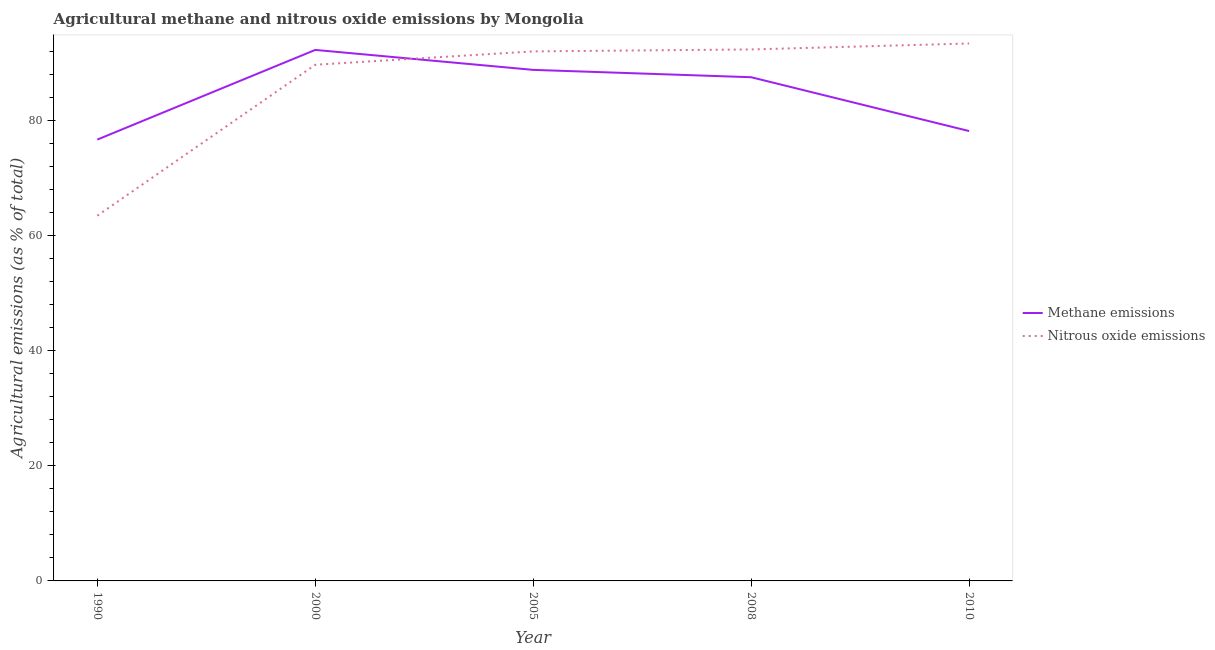How many different coloured lines are there?
Your answer should be very brief. 2. What is the amount of methane emissions in 2010?
Your answer should be very brief. 78.14. Across all years, what is the maximum amount of methane emissions?
Offer a very short reply. 92.24. Across all years, what is the minimum amount of methane emissions?
Your response must be concise. 76.66. In which year was the amount of methane emissions minimum?
Offer a terse response. 1990. What is the total amount of methane emissions in the graph?
Your answer should be compact. 423.3. What is the difference between the amount of nitrous oxide emissions in 2008 and that in 2010?
Provide a succinct answer. -1.03. What is the difference between the amount of nitrous oxide emissions in 2005 and the amount of methane emissions in 1990?
Keep it short and to the point. 15.32. What is the average amount of nitrous oxide emissions per year?
Offer a terse response. 86.15. In the year 2010, what is the difference between the amount of methane emissions and amount of nitrous oxide emissions?
Your response must be concise. -15.21. In how many years, is the amount of nitrous oxide emissions greater than 52 %?
Give a very brief answer. 5. What is the ratio of the amount of methane emissions in 2008 to that in 2010?
Provide a succinct answer. 1.12. Is the amount of methane emissions in 1990 less than that in 2005?
Your answer should be very brief. Yes. What is the difference between the highest and the second highest amount of nitrous oxide emissions?
Provide a short and direct response. 1.03. What is the difference between the highest and the lowest amount of methane emissions?
Offer a terse response. 15.58. In how many years, is the amount of methane emissions greater than the average amount of methane emissions taken over all years?
Your answer should be compact. 3. Is the sum of the amount of methane emissions in 1990 and 2000 greater than the maximum amount of nitrous oxide emissions across all years?
Ensure brevity in your answer.  Yes. Does the amount of nitrous oxide emissions monotonically increase over the years?
Offer a very short reply. Yes. Is the amount of methane emissions strictly greater than the amount of nitrous oxide emissions over the years?
Keep it short and to the point. No. Is the amount of methane emissions strictly less than the amount of nitrous oxide emissions over the years?
Your response must be concise. No. How many years are there in the graph?
Provide a succinct answer. 5. What is the difference between two consecutive major ticks on the Y-axis?
Your answer should be very brief. 20. Are the values on the major ticks of Y-axis written in scientific E-notation?
Provide a succinct answer. No. Does the graph contain grids?
Offer a terse response. No. How many legend labels are there?
Provide a short and direct response. 2. How are the legend labels stacked?
Provide a short and direct response. Vertical. What is the title of the graph?
Offer a very short reply. Agricultural methane and nitrous oxide emissions by Mongolia. What is the label or title of the X-axis?
Give a very brief answer. Year. What is the label or title of the Y-axis?
Offer a very short reply. Agricultural emissions (as % of total). What is the Agricultural emissions (as % of total) of Methane emissions in 1990?
Keep it short and to the point. 76.66. What is the Agricultural emissions (as % of total) of Nitrous oxide emissions in 1990?
Give a very brief answer. 63.44. What is the Agricultural emissions (as % of total) in Methane emissions in 2000?
Your answer should be very brief. 92.24. What is the Agricultural emissions (as % of total) of Nitrous oxide emissions in 2000?
Provide a short and direct response. 89.66. What is the Agricultural emissions (as % of total) of Methane emissions in 2005?
Provide a succinct answer. 88.77. What is the Agricultural emissions (as % of total) of Nitrous oxide emissions in 2005?
Your answer should be compact. 91.98. What is the Agricultural emissions (as % of total) in Methane emissions in 2008?
Give a very brief answer. 87.49. What is the Agricultural emissions (as % of total) in Nitrous oxide emissions in 2008?
Ensure brevity in your answer.  92.32. What is the Agricultural emissions (as % of total) in Methane emissions in 2010?
Make the answer very short. 78.14. What is the Agricultural emissions (as % of total) of Nitrous oxide emissions in 2010?
Keep it short and to the point. 93.35. Across all years, what is the maximum Agricultural emissions (as % of total) of Methane emissions?
Offer a very short reply. 92.24. Across all years, what is the maximum Agricultural emissions (as % of total) of Nitrous oxide emissions?
Provide a succinct answer. 93.35. Across all years, what is the minimum Agricultural emissions (as % of total) of Methane emissions?
Offer a very short reply. 76.66. Across all years, what is the minimum Agricultural emissions (as % of total) of Nitrous oxide emissions?
Give a very brief answer. 63.44. What is the total Agricultural emissions (as % of total) of Methane emissions in the graph?
Provide a short and direct response. 423.3. What is the total Agricultural emissions (as % of total) of Nitrous oxide emissions in the graph?
Keep it short and to the point. 430.75. What is the difference between the Agricultural emissions (as % of total) of Methane emissions in 1990 and that in 2000?
Make the answer very short. -15.58. What is the difference between the Agricultural emissions (as % of total) of Nitrous oxide emissions in 1990 and that in 2000?
Give a very brief answer. -26.22. What is the difference between the Agricultural emissions (as % of total) in Methane emissions in 1990 and that in 2005?
Your response must be concise. -12.11. What is the difference between the Agricultural emissions (as % of total) in Nitrous oxide emissions in 1990 and that in 2005?
Offer a very short reply. -28.54. What is the difference between the Agricultural emissions (as % of total) in Methane emissions in 1990 and that in 2008?
Offer a terse response. -10.83. What is the difference between the Agricultural emissions (as % of total) in Nitrous oxide emissions in 1990 and that in 2008?
Your answer should be compact. -28.88. What is the difference between the Agricultural emissions (as % of total) of Methane emissions in 1990 and that in 2010?
Your answer should be very brief. -1.48. What is the difference between the Agricultural emissions (as % of total) of Nitrous oxide emissions in 1990 and that in 2010?
Ensure brevity in your answer.  -29.91. What is the difference between the Agricultural emissions (as % of total) of Methane emissions in 2000 and that in 2005?
Offer a terse response. 3.47. What is the difference between the Agricultural emissions (as % of total) of Nitrous oxide emissions in 2000 and that in 2005?
Make the answer very short. -2.32. What is the difference between the Agricultural emissions (as % of total) in Methane emissions in 2000 and that in 2008?
Offer a terse response. 4.74. What is the difference between the Agricultural emissions (as % of total) of Nitrous oxide emissions in 2000 and that in 2008?
Your answer should be very brief. -2.66. What is the difference between the Agricultural emissions (as % of total) in Methane emissions in 2000 and that in 2010?
Your response must be concise. 14.1. What is the difference between the Agricultural emissions (as % of total) of Nitrous oxide emissions in 2000 and that in 2010?
Provide a short and direct response. -3.7. What is the difference between the Agricultural emissions (as % of total) of Methane emissions in 2005 and that in 2008?
Provide a short and direct response. 1.28. What is the difference between the Agricultural emissions (as % of total) in Nitrous oxide emissions in 2005 and that in 2008?
Give a very brief answer. -0.34. What is the difference between the Agricultural emissions (as % of total) of Methane emissions in 2005 and that in 2010?
Provide a succinct answer. 10.63. What is the difference between the Agricultural emissions (as % of total) of Nitrous oxide emissions in 2005 and that in 2010?
Ensure brevity in your answer.  -1.37. What is the difference between the Agricultural emissions (as % of total) of Methane emissions in 2008 and that in 2010?
Offer a terse response. 9.35. What is the difference between the Agricultural emissions (as % of total) in Nitrous oxide emissions in 2008 and that in 2010?
Your answer should be compact. -1.03. What is the difference between the Agricultural emissions (as % of total) of Methane emissions in 1990 and the Agricultural emissions (as % of total) of Nitrous oxide emissions in 2000?
Make the answer very short. -13. What is the difference between the Agricultural emissions (as % of total) of Methane emissions in 1990 and the Agricultural emissions (as % of total) of Nitrous oxide emissions in 2005?
Ensure brevity in your answer.  -15.32. What is the difference between the Agricultural emissions (as % of total) in Methane emissions in 1990 and the Agricultural emissions (as % of total) in Nitrous oxide emissions in 2008?
Offer a terse response. -15.66. What is the difference between the Agricultural emissions (as % of total) of Methane emissions in 1990 and the Agricultural emissions (as % of total) of Nitrous oxide emissions in 2010?
Offer a very short reply. -16.69. What is the difference between the Agricultural emissions (as % of total) in Methane emissions in 2000 and the Agricultural emissions (as % of total) in Nitrous oxide emissions in 2005?
Make the answer very short. 0.26. What is the difference between the Agricultural emissions (as % of total) of Methane emissions in 2000 and the Agricultural emissions (as % of total) of Nitrous oxide emissions in 2008?
Your answer should be very brief. -0.08. What is the difference between the Agricultural emissions (as % of total) of Methane emissions in 2000 and the Agricultural emissions (as % of total) of Nitrous oxide emissions in 2010?
Offer a terse response. -1.12. What is the difference between the Agricultural emissions (as % of total) of Methane emissions in 2005 and the Agricultural emissions (as % of total) of Nitrous oxide emissions in 2008?
Provide a succinct answer. -3.55. What is the difference between the Agricultural emissions (as % of total) of Methane emissions in 2005 and the Agricultural emissions (as % of total) of Nitrous oxide emissions in 2010?
Your response must be concise. -4.58. What is the difference between the Agricultural emissions (as % of total) in Methane emissions in 2008 and the Agricultural emissions (as % of total) in Nitrous oxide emissions in 2010?
Provide a short and direct response. -5.86. What is the average Agricultural emissions (as % of total) in Methane emissions per year?
Keep it short and to the point. 84.66. What is the average Agricultural emissions (as % of total) in Nitrous oxide emissions per year?
Your answer should be compact. 86.15. In the year 1990, what is the difference between the Agricultural emissions (as % of total) in Methane emissions and Agricultural emissions (as % of total) in Nitrous oxide emissions?
Your answer should be very brief. 13.22. In the year 2000, what is the difference between the Agricultural emissions (as % of total) in Methane emissions and Agricultural emissions (as % of total) in Nitrous oxide emissions?
Offer a terse response. 2.58. In the year 2005, what is the difference between the Agricultural emissions (as % of total) of Methane emissions and Agricultural emissions (as % of total) of Nitrous oxide emissions?
Provide a short and direct response. -3.21. In the year 2008, what is the difference between the Agricultural emissions (as % of total) in Methane emissions and Agricultural emissions (as % of total) in Nitrous oxide emissions?
Provide a succinct answer. -4.83. In the year 2010, what is the difference between the Agricultural emissions (as % of total) of Methane emissions and Agricultural emissions (as % of total) of Nitrous oxide emissions?
Provide a short and direct response. -15.21. What is the ratio of the Agricultural emissions (as % of total) of Methane emissions in 1990 to that in 2000?
Your answer should be very brief. 0.83. What is the ratio of the Agricultural emissions (as % of total) in Nitrous oxide emissions in 1990 to that in 2000?
Offer a terse response. 0.71. What is the ratio of the Agricultural emissions (as % of total) in Methane emissions in 1990 to that in 2005?
Your answer should be compact. 0.86. What is the ratio of the Agricultural emissions (as % of total) in Nitrous oxide emissions in 1990 to that in 2005?
Provide a succinct answer. 0.69. What is the ratio of the Agricultural emissions (as % of total) of Methane emissions in 1990 to that in 2008?
Offer a very short reply. 0.88. What is the ratio of the Agricultural emissions (as % of total) in Nitrous oxide emissions in 1990 to that in 2008?
Make the answer very short. 0.69. What is the ratio of the Agricultural emissions (as % of total) of Methane emissions in 1990 to that in 2010?
Offer a very short reply. 0.98. What is the ratio of the Agricultural emissions (as % of total) in Nitrous oxide emissions in 1990 to that in 2010?
Ensure brevity in your answer.  0.68. What is the ratio of the Agricultural emissions (as % of total) in Methane emissions in 2000 to that in 2005?
Your answer should be compact. 1.04. What is the ratio of the Agricultural emissions (as % of total) of Nitrous oxide emissions in 2000 to that in 2005?
Offer a very short reply. 0.97. What is the ratio of the Agricultural emissions (as % of total) of Methane emissions in 2000 to that in 2008?
Provide a short and direct response. 1.05. What is the ratio of the Agricultural emissions (as % of total) in Nitrous oxide emissions in 2000 to that in 2008?
Provide a succinct answer. 0.97. What is the ratio of the Agricultural emissions (as % of total) in Methane emissions in 2000 to that in 2010?
Make the answer very short. 1.18. What is the ratio of the Agricultural emissions (as % of total) in Nitrous oxide emissions in 2000 to that in 2010?
Provide a short and direct response. 0.96. What is the ratio of the Agricultural emissions (as % of total) of Methane emissions in 2005 to that in 2008?
Your answer should be compact. 1.01. What is the ratio of the Agricultural emissions (as % of total) of Methane emissions in 2005 to that in 2010?
Offer a terse response. 1.14. What is the ratio of the Agricultural emissions (as % of total) in Nitrous oxide emissions in 2005 to that in 2010?
Provide a short and direct response. 0.99. What is the ratio of the Agricultural emissions (as % of total) of Methane emissions in 2008 to that in 2010?
Provide a succinct answer. 1.12. What is the ratio of the Agricultural emissions (as % of total) in Nitrous oxide emissions in 2008 to that in 2010?
Your response must be concise. 0.99. What is the difference between the highest and the second highest Agricultural emissions (as % of total) in Methane emissions?
Give a very brief answer. 3.47. What is the difference between the highest and the second highest Agricultural emissions (as % of total) in Nitrous oxide emissions?
Your answer should be very brief. 1.03. What is the difference between the highest and the lowest Agricultural emissions (as % of total) in Methane emissions?
Ensure brevity in your answer.  15.58. What is the difference between the highest and the lowest Agricultural emissions (as % of total) of Nitrous oxide emissions?
Give a very brief answer. 29.91. 